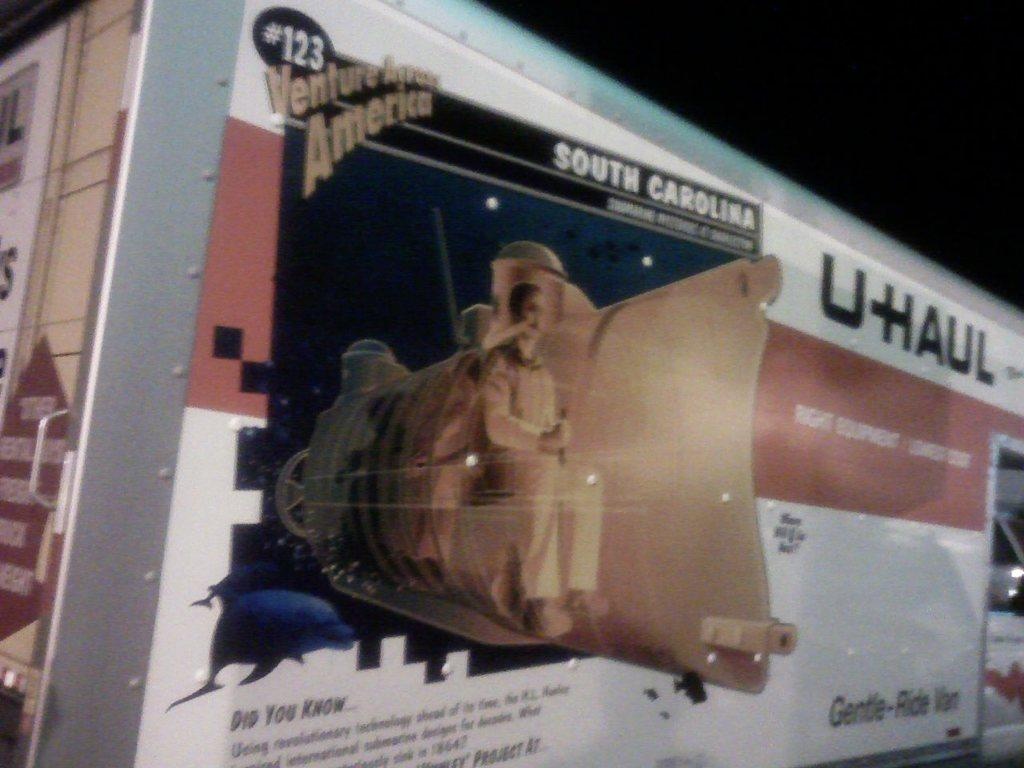What is the main subject of the image? The main subject of the image is a vehicle. What feature is attached to the vehicle? The vehicle has a banner. What is depicted on the banner? There is a man on the banner. What is the man doing on the banner? The man is sitting on iron equipment. What text is written on the banner? The banner has the text "U HAUL" written on it. Can you see the man's elbow in the image? There is no visible elbow in the image; the focus is on the man sitting on iron equipment on the banner. 